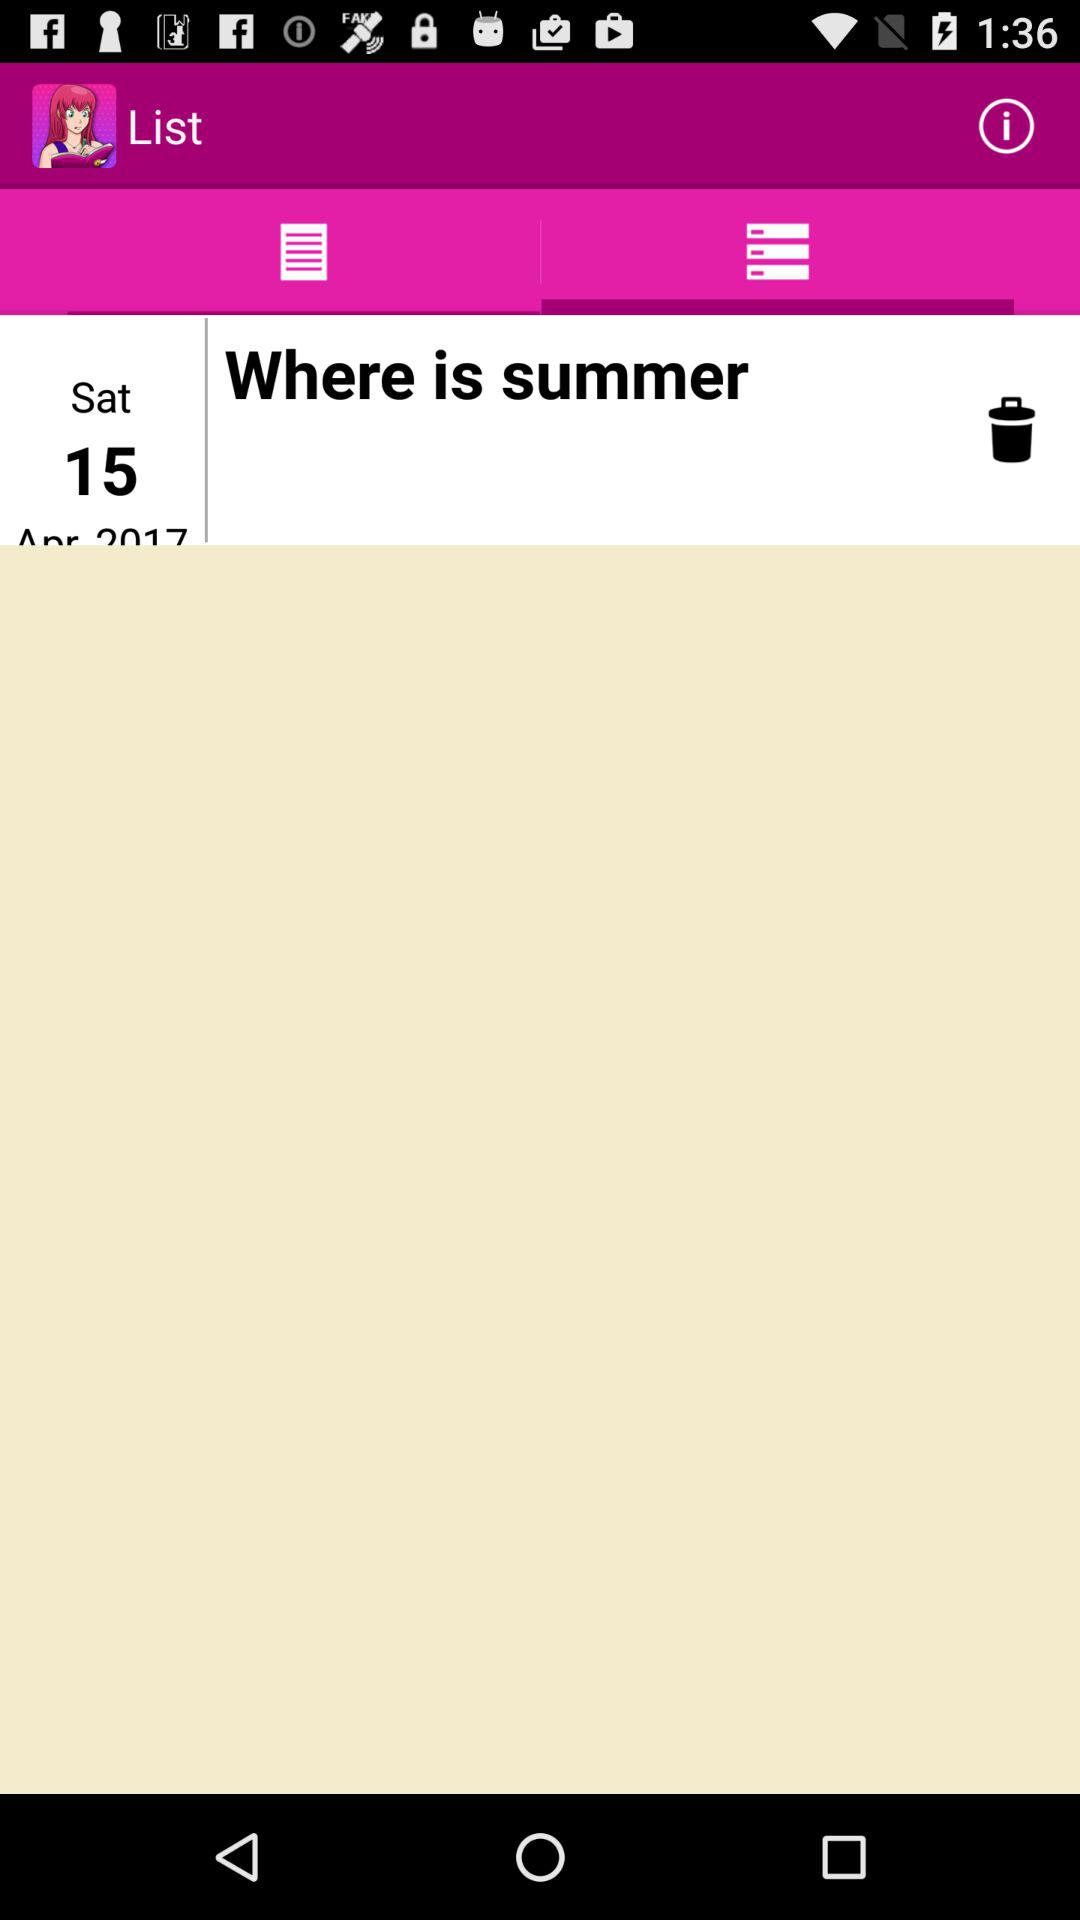What is the mentioned date? The date is Saturday, 15 April 17. 